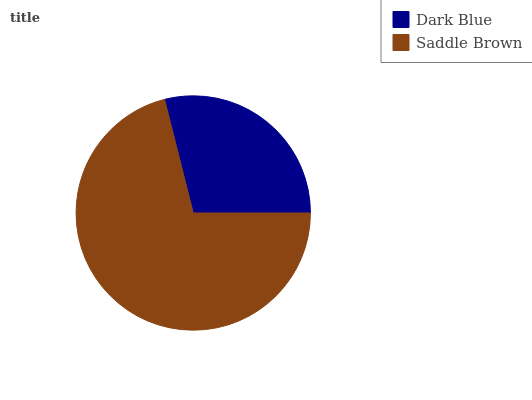Is Dark Blue the minimum?
Answer yes or no. Yes. Is Saddle Brown the maximum?
Answer yes or no. Yes. Is Saddle Brown the minimum?
Answer yes or no. No. Is Saddle Brown greater than Dark Blue?
Answer yes or no. Yes. Is Dark Blue less than Saddle Brown?
Answer yes or no. Yes. Is Dark Blue greater than Saddle Brown?
Answer yes or no. No. Is Saddle Brown less than Dark Blue?
Answer yes or no. No. Is Saddle Brown the high median?
Answer yes or no. Yes. Is Dark Blue the low median?
Answer yes or no. Yes. Is Dark Blue the high median?
Answer yes or no. No. Is Saddle Brown the low median?
Answer yes or no. No. 